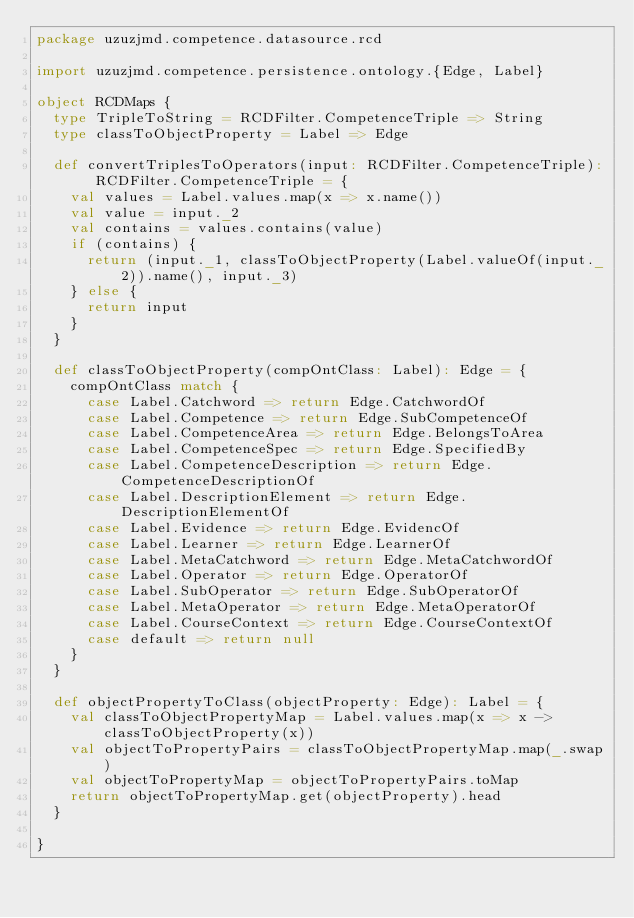<code> <loc_0><loc_0><loc_500><loc_500><_Scala_>package uzuzjmd.competence.datasource.rcd

import uzuzjmd.competence.persistence.ontology.{Edge, Label}

object RCDMaps {
  type TripleToString = RCDFilter.CompetenceTriple => String
  type classToObjectProperty = Label => Edge

  def convertTriplesToOperators(input: RCDFilter.CompetenceTriple): RCDFilter.CompetenceTriple = {
    val values = Label.values.map(x => x.name())
    val value = input._2
    val contains = values.contains(value)
    if (contains) {
      return (input._1, classToObjectProperty(Label.valueOf(input._2)).name(), input._3)
    } else {
      return input
    }
  }

  def classToObjectProperty(compOntClass: Label): Edge = {
    compOntClass match {
      case Label.Catchword => return Edge.CatchwordOf
      case Label.Competence => return Edge.SubCompetenceOf
      case Label.CompetenceArea => return Edge.BelongsToArea
      case Label.CompetenceSpec => return Edge.SpecifiedBy
      case Label.CompetenceDescription => return Edge.CompetenceDescriptionOf
      case Label.DescriptionElement => return Edge.DescriptionElementOf
      case Label.Evidence => return Edge.EvidencOf
      case Label.Learner => return Edge.LearnerOf
      case Label.MetaCatchword => return Edge.MetaCatchwordOf
      case Label.Operator => return Edge.OperatorOf
      case Label.SubOperator => return Edge.SubOperatorOf
      case Label.MetaOperator => return Edge.MetaOperatorOf
      case Label.CourseContext => return Edge.CourseContextOf
      case default => return null
    }
  }

  def objectPropertyToClass(objectProperty: Edge): Label = {
    val classToObjectPropertyMap = Label.values.map(x => x -> classToObjectProperty(x))
    val objectToPropertyPairs = classToObjectPropertyMap.map(_.swap)
    val objectToPropertyMap = objectToPropertyPairs.toMap
    return objectToPropertyMap.get(objectProperty).head
  }

}</code> 